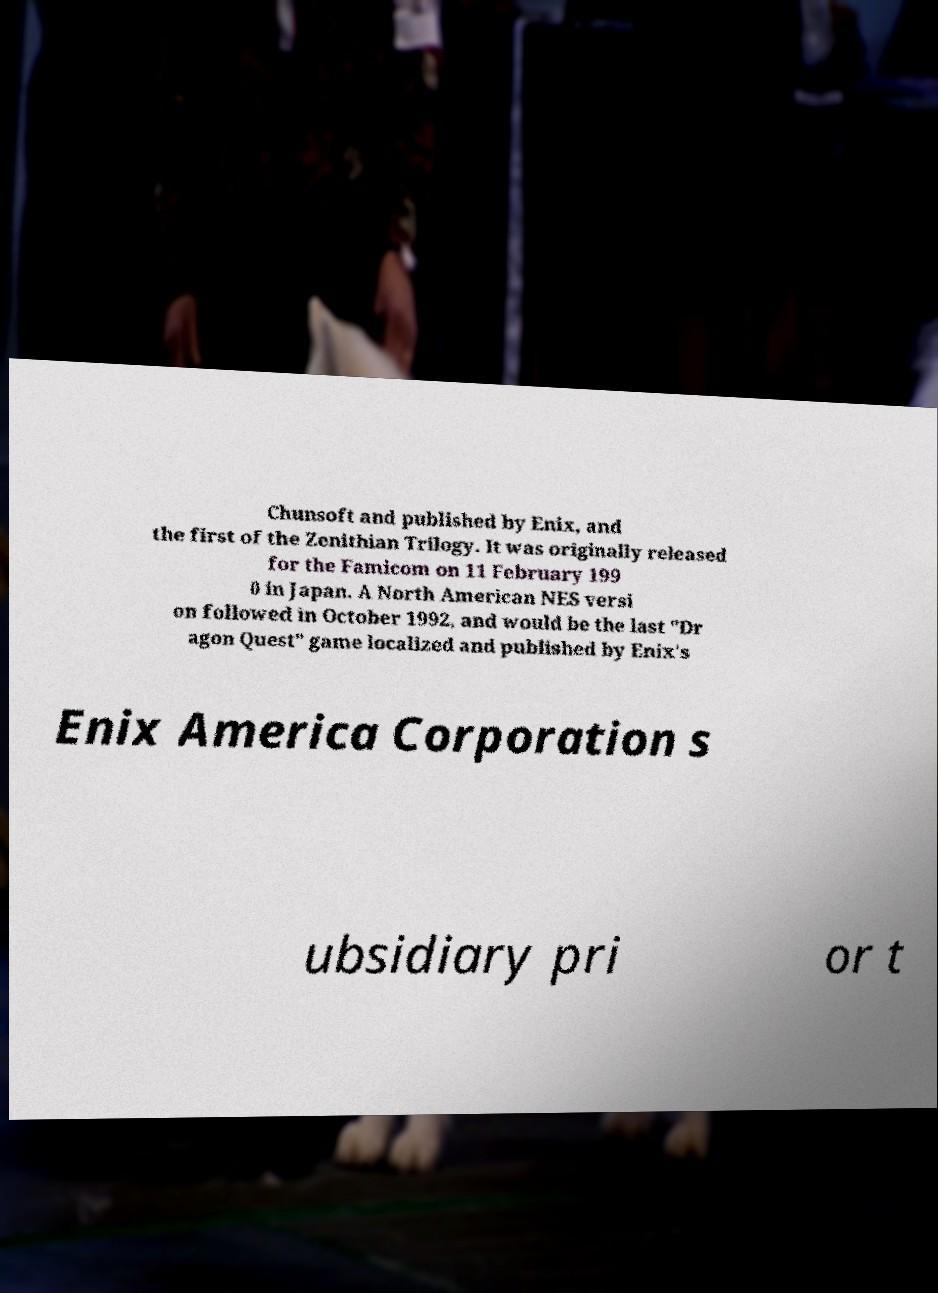For documentation purposes, I need the text within this image transcribed. Could you provide that? Chunsoft and published by Enix, and the first of the Zenithian Trilogy. It was originally released for the Famicom on 11 February 199 0 in Japan. A North American NES versi on followed in October 1992, and would be the last "Dr agon Quest" game localized and published by Enix's Enix America Corporation s ubsidiary pri or t 